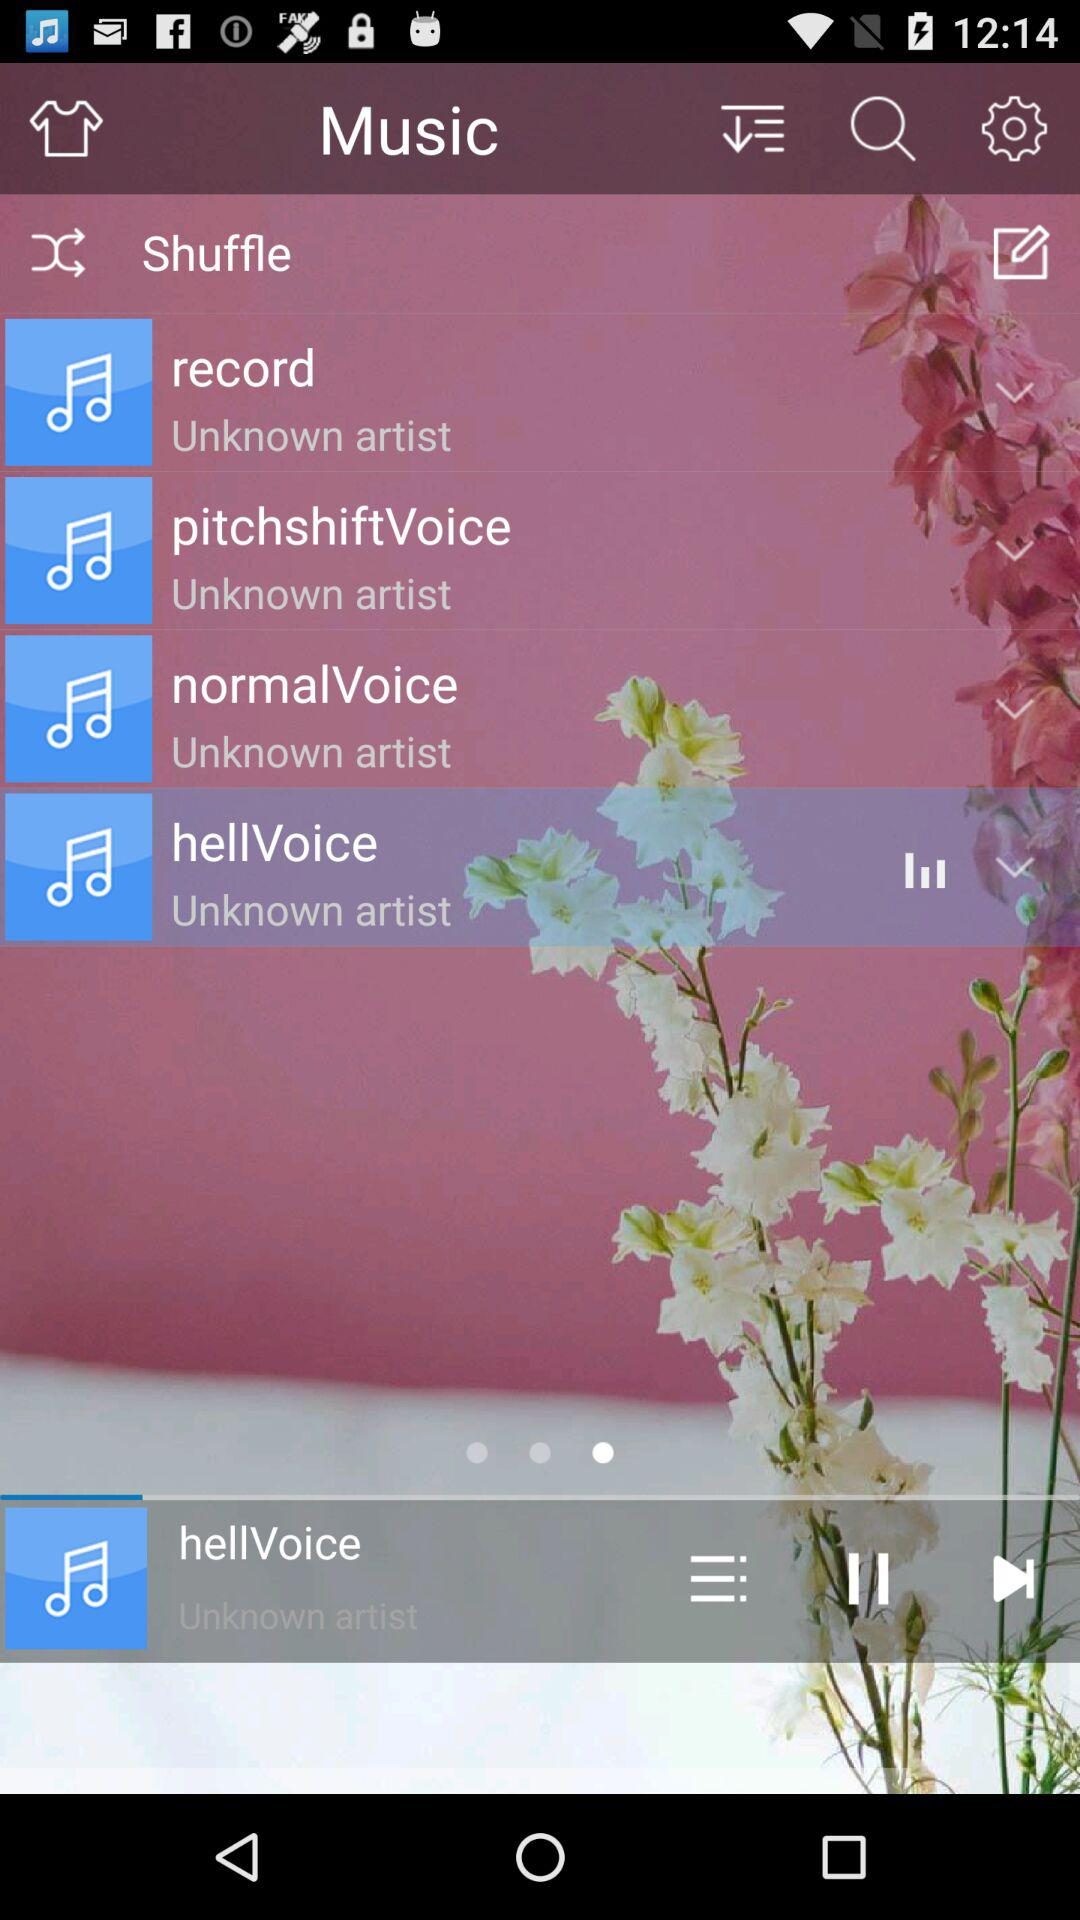How long is "record"?
When the provided information is insufficient, respond with <no answer>. <no answer> 